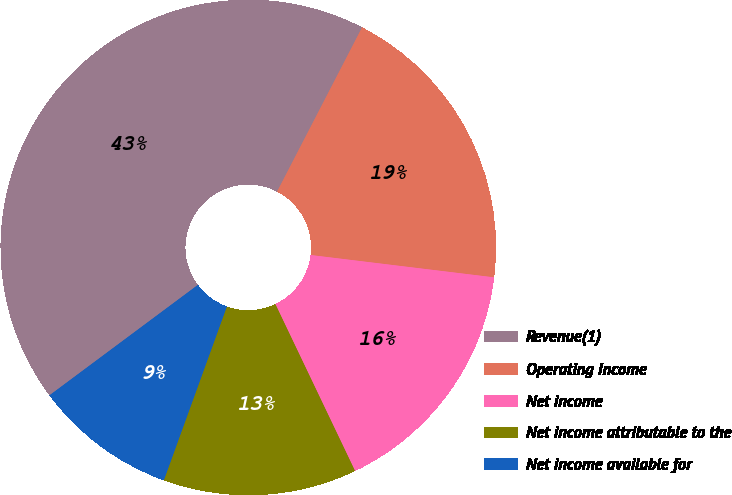Convert chart to OTSL. <chart><loc_0><loc_0><loc_500><loc_500><pie_chart><fcel>Revenue(1)<fcel>Operating Income<fcel>Net income<fcel>Net income attributable to the<fcel>Net income available for<nl><fcel>42.78%<fcel>19.33%<fcel>15.98%<fcel>12.63%<fcel>9.28%<nl></chart> 